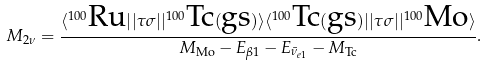<formula> <loc_0><loc_0><loc_500><loc_500>M _ { 2 \nu } = \frac { \langle ^ { 1 0 0 } \text {Ru} | | \tau \sigma | | ^ { 1 0 0 } \text {Tc} ( \text {gs} ) \rangle \langle ^ { 1 0 0 } \text {Tc} ( \text {gs} ) | | \tau \sigma | | ^ { 1 0 0 } \text {Mo} \rangle } { M _ { \text {Mo} } - E _ { \beta 1 } - E _ { { \bar { \nu } } _ { e 1 } } - M _ { \text {Tc} } } .</formula> 